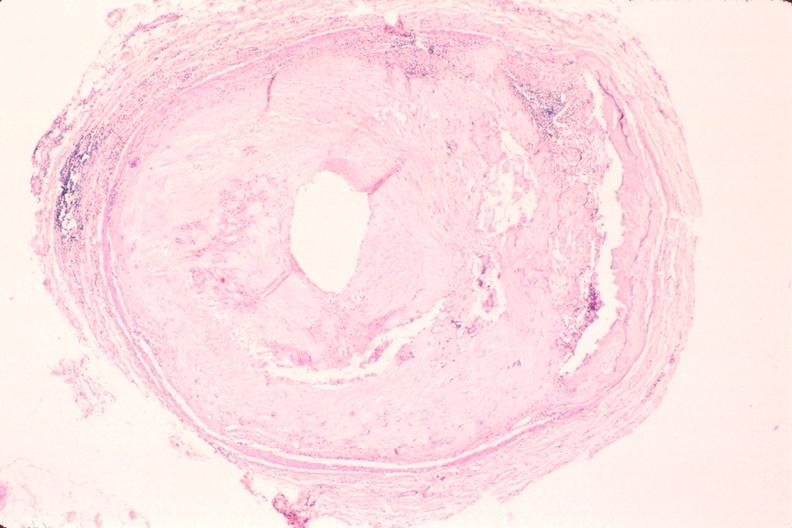what is present?
Answer the question using a single word or phrase. Cardiovascular 